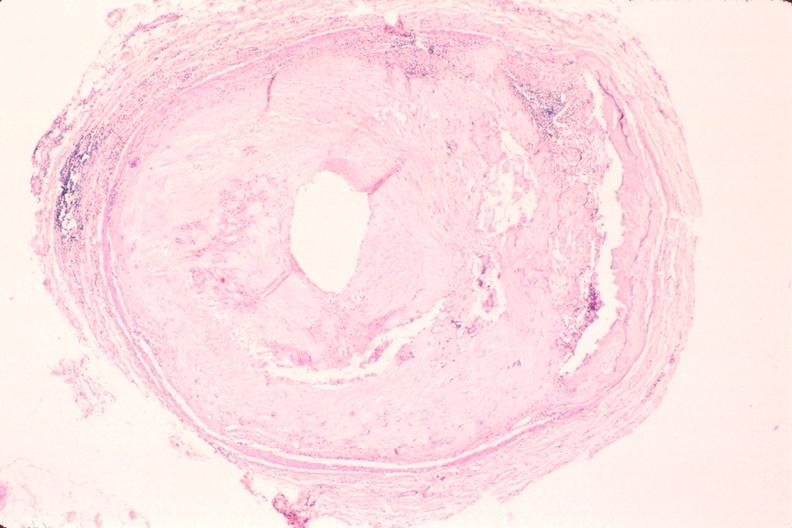what is present?
Answer the question using a single word or phrase. Cardiovascular 